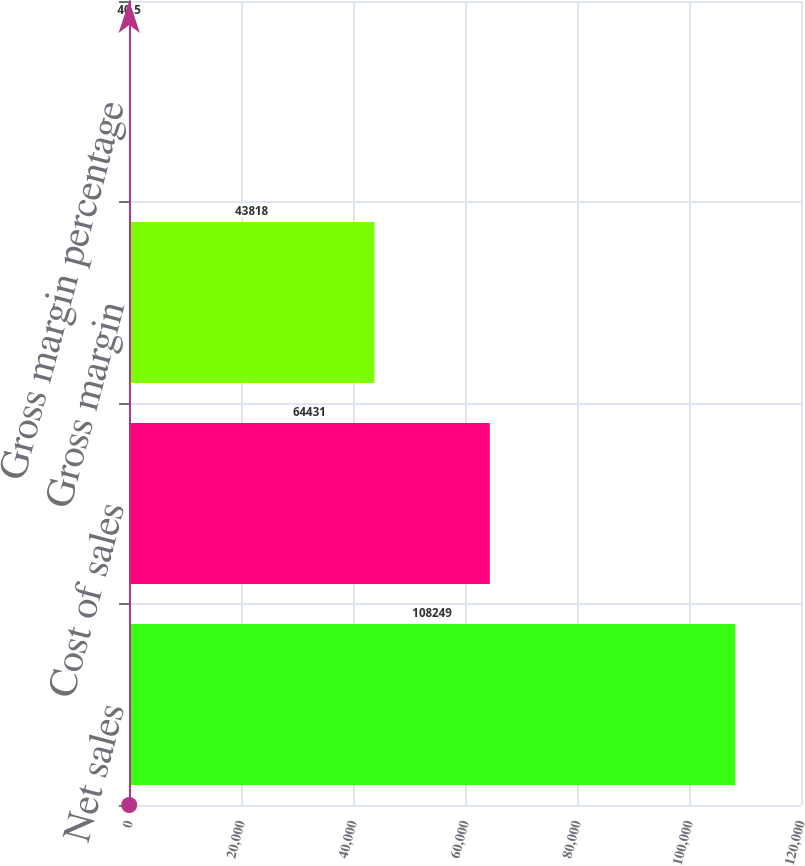<chart> <loc_0><loc_0><loc_500><loc_500><bar_chart><fcel>Net sales<fcel>Cost of sales<fcel>Gross margin<fcel>Gross margin percentage<nl><fcel>108249<fcel>64431<fcel>43818<fcel>40.5<nl></chart> 